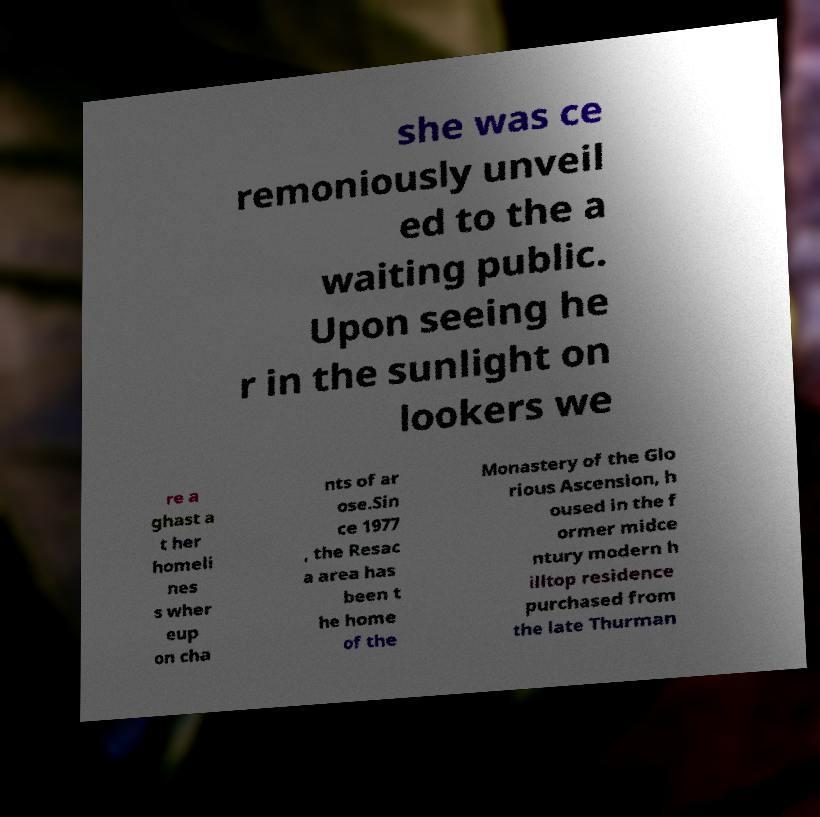Can you accurately transcribe the text from the provided image for me? she was ce remoniously unveil ed to the a waiting public. Upon seeing he r in the sunlight on lookers we re a ghast a t her homeli nes s wher eup on cha nts of ar ose.Sin ce 1977 , the Resac a area has been t he home of the Monastery of the Glo rious Ascension, h oused in the f ormer midce ntury modern h illtop residence purchased from the late Thurman 